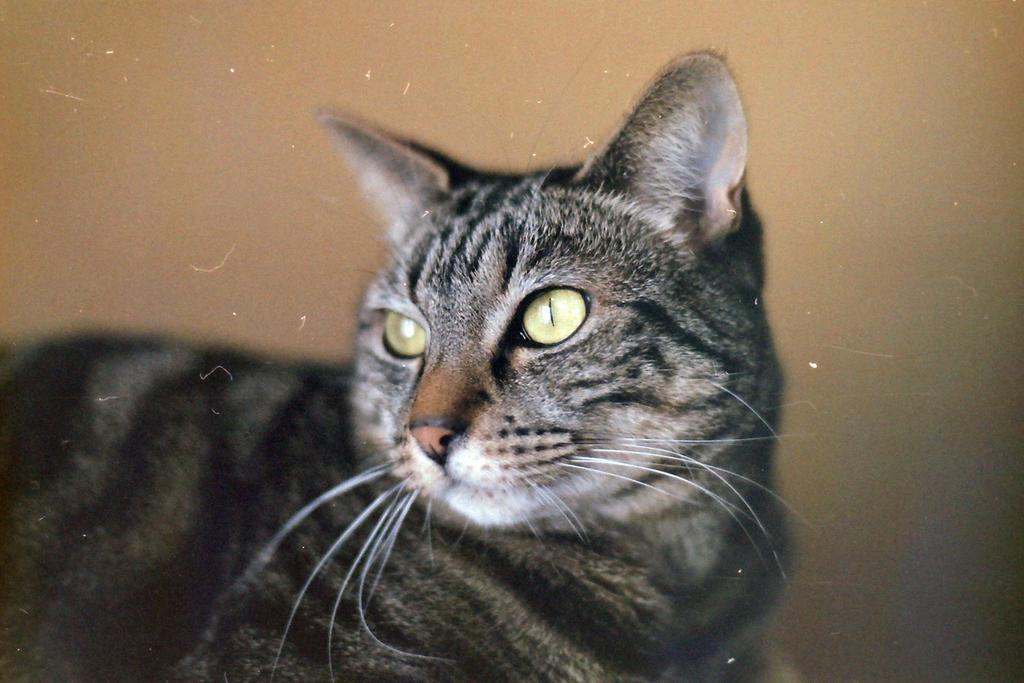What animal is in the foreground of the image? There is a cat in the foreground of the image. What can be seen in the background of the image? There is a wall in the background of the image. How many pigs are visible in the image? There are no pigs present in the image; it features a cat in the foreground and a wall in the background. 